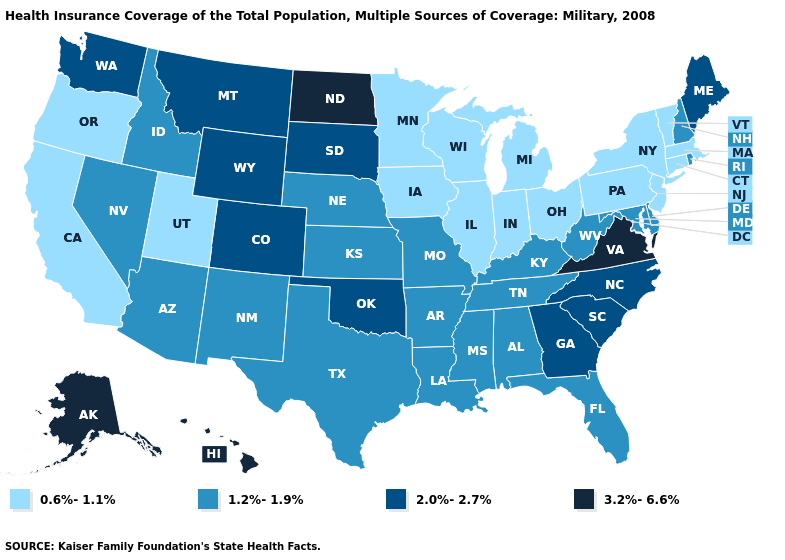Among the states that border Indiana , which have the lowest value?
Write a very short answer. Illinois, Michigan, Ohio. Which states hav the highest value in the West?
Keep it brief. Alaska, Hawaii. What is the value of Georgia?
Be succinct. 2.0%-2.7%. Name the states that have a value in the range 3.2%-6.6%?
Answer briefly. Alaska, Hawaii, North Dakota, Virginia. Name the states that have a value in the range 3.2%-6.6%?
Give a very brief answer. Alaska, Hawaii, North Dakota, Virginia. What is the lowest value in the South?
Quick response, please. 1.2%-1.9%. Name the states that have a value in the range 2.0%-2.7%?
Be succinct. Colorado, Georgia, Maine, Montana, North Carolina, Oklahoma, South Carolina, South Dakota, Washington, Wyoming. What is the value of South Carolina?
Give a very brief answer. 2.0%-2.7%. What is the value of West Virginia?
Write a very short answer. 1.2%-1.9%. Is the legend a continuous bar?
Short answer required. No. Does the map have missing data?
Write a very short answer. No. What is the value of South Carolina?
Short answer required. 2.0%-2.7%. What is the value of Iowa?
Answer briefly. 0.6%-1.1%. What is the highest value in the South ?
Short answer required. 3.2%-6.6%. Among the states that border Montana , which have the lowest value?
Give a very brief answer. Idaho. 